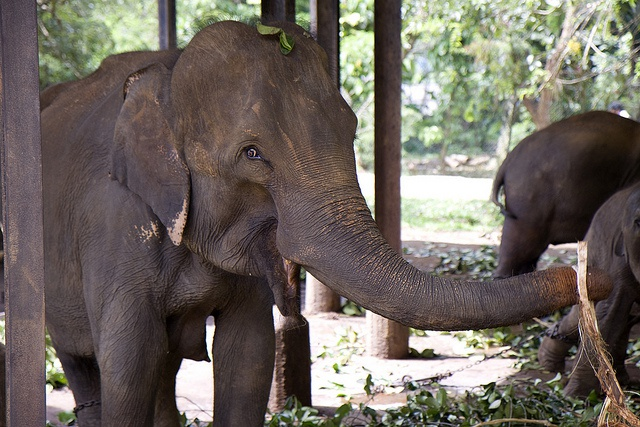Describe the objects in this image and their specific colors. I can see elephant in black, gray, and maroon tones, elephant in black and gray tones, and elephant in black and gray tones in this image. 